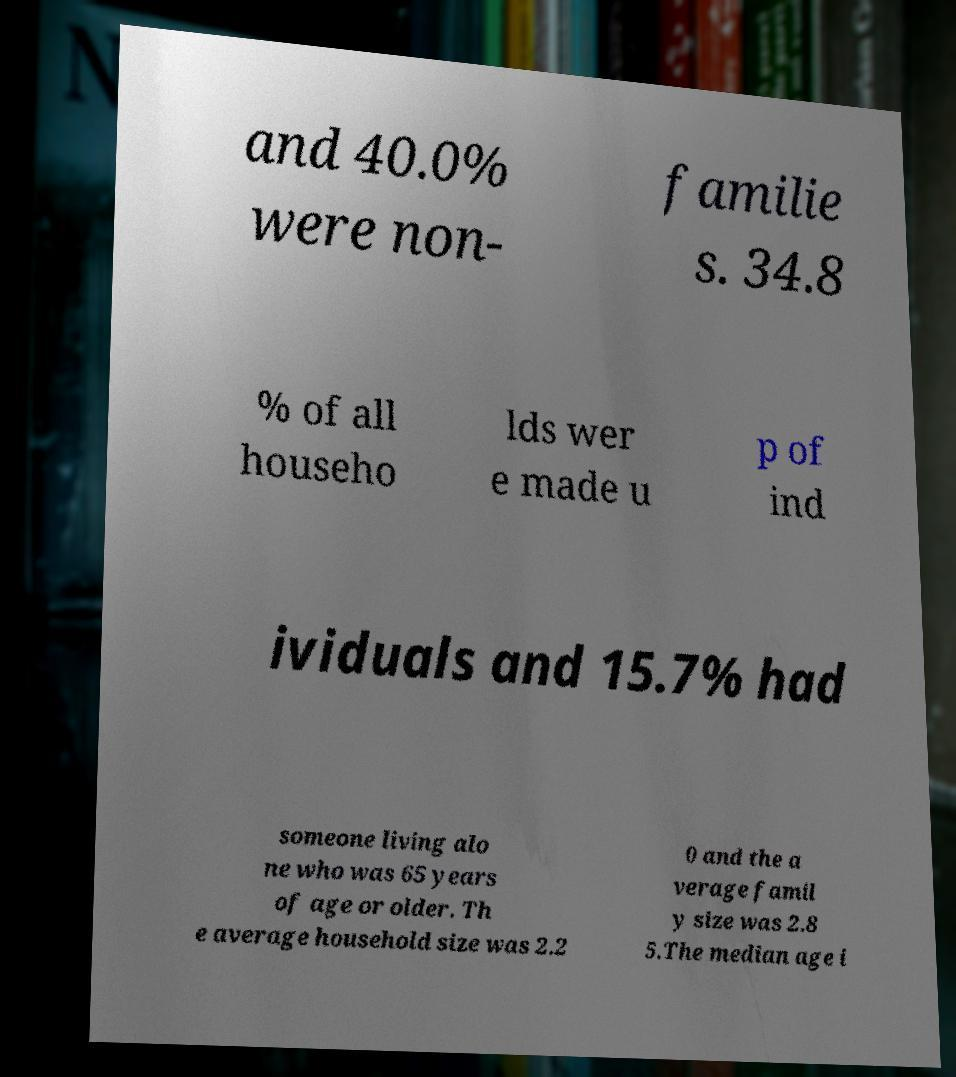For documentation purposes, I need the text within this image transcribed. Could you provide that? and 40.0% were non- familie s. 34.8 % of all househo lds wer e made u p of ind ividuals and 15.7% had someone living alo ne who was 65 years of age or older. Th e average household size was 2.2 0 and the a verage famil y size was 2.8 5.The median age i 